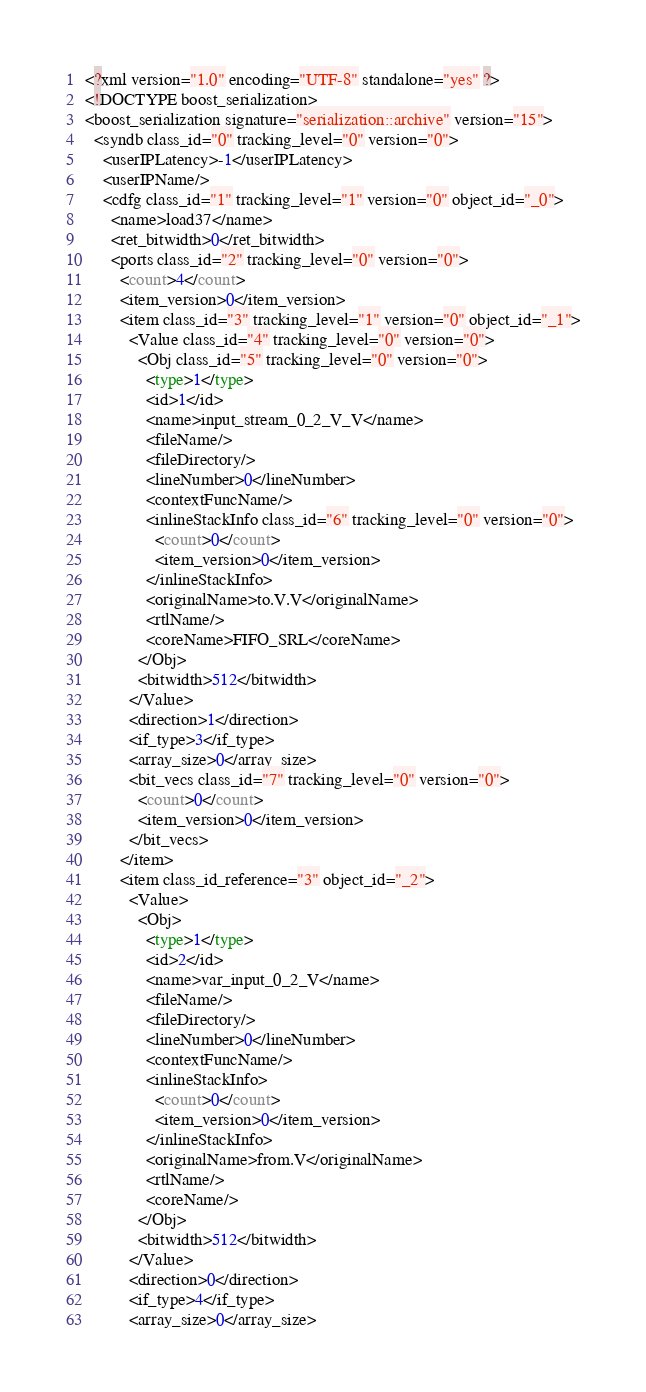<code> <loc_0><loc_0><loc_500><loc_500><_Ada_><?xml version="1.0" encoding="UTF-8" standalone="yes" ?>
<!DOCTYPE boost_serialization>
<boost_serialization signature="serialization::archive" version="15">
  <syndb class_id="0" tracking_level="0" version="0">
    <userIPLatency>-1</userIPLatency>
    <userIPName/>
    <cdfg class_id="1" tracking_level="1" version="0" object_id="_0">
      <name>load37</name>
      <ret_bitwidth>0</ret_bitwidth>
      <ports class_id="2" tracking_level="0" version="0">
        <count>4</count>
        <item_version>0</item_version>
        <item class_id="3" tracking_level="1" version="0" object_id="_1">
          <Value class_id="4" tracking_level="0" version="0">
            <Obj class_id="5" tracking_level="0" version="0">
              <type>1</type>
              <id>1</id>
              <name>input_stream_0_2_V_V</name>
              <fileName/>
              <fileDirectory/>
              <lineNumber>0</lineNumber>
              <contextFuncName/>
              <inlineStackInfo class_id="6" tracking_level="0" version="0">
                <count>0</count>
                <item_version>0</item_version>
              </inlineStackInfo>
              <originalName>to.V.V</originalName>
              <rtlName/>
              <coreName>FIFO_SRL</coreName>
            </Obj>
            <bitwidth>512</bitwidth>
          </Value>
          <direction>1</direction>
          <if_type>3</if_type>
          <array_size>0</array_size>
          <bit_vecs class_id="7" tracking_level="0" version="0">
            <count>0</count>
            <item_version>0</item_version>
          </bit_vecs>
        </item>
        <item class_id_reference="3" object_id="_2">
          <Value>
            <Obj>
              <type>1</type>
              <id>2</id>
              <name>var_input_0_2_V</name>
              <fileName/>
              <fileDirectory/>
              <lineNumber>0</lineNumber>
              <contextFuncName/>
              <inlineStackInfo>
                <count>0</count>
                <item_version>0</item_version>
              </inlineStackInfo>
              <originalName>from.V</originalName>
              <rtlName/>
              <coreName/>
            </Obj>
            <bitwidth>512</bitwidth>
          </Value>
          <direction>0</direction>
          <if_type>4</if_type>
          <array_size>0</array_size></code> 